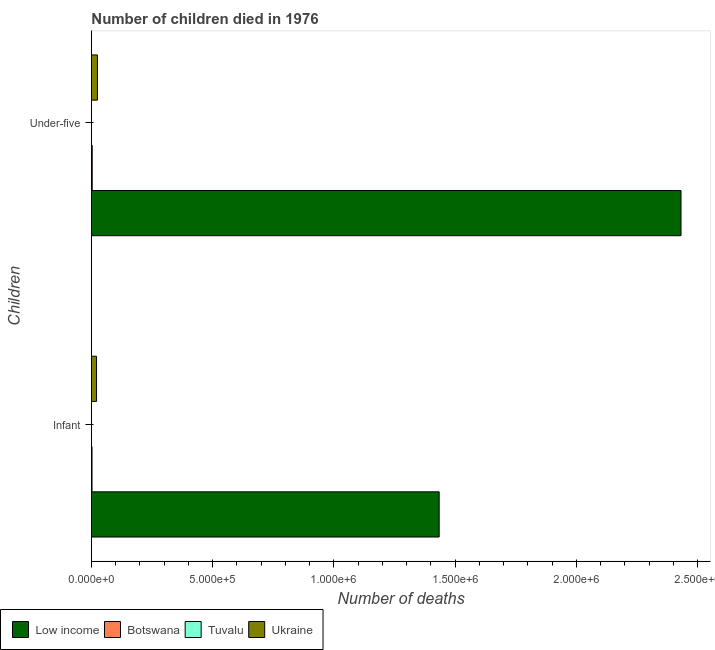How many different coloured bars are there?
Ensure brevity in your answer.  4. Are the number of bars per tick equal to the number of legend labels?
Offer a terse response. Yes. What is the label of the 2nd group of bars from the top?
Offer a terse response. Infant. What is the number of under-five deaths in Low income?
Keep it short and to the point. 2.43e+06. Across all countries, what is the maximum number of infant deaths?
Provide a short and direct response. 1.43e+06. Across all countries, what is the minimum number of under-five deaths?
Your answer should be compact. 15. In which country was the number of infant deaths minimum?
Make the answer very short. Tuvalu. What is the total number of infant deaths in the graph?
Make the answer very short. 1.46e+06. What is the difference between the number of under-five deaths in Tuvalu and that in Ukraine?
Provide a short and direct response. -2.48e+04. What is the difference between the number of infant deaths in Botswana and the number of under-five deaths in Low income?
Your answer should be compact. -2.43e+06. What is the average number of infant deaths per country?
Ensure brevity in your answer.  3.64e+05. What is the difference between the number of infant deaths and number of under-five deaths in Low income?
Offer a very short reply. -9.97e+05. In how many countries, is the number of infant deaths greater than 1200000 ?
Offer a terse response. 1. What is the ratio of the number of under-five deaths in Ukraine to that in Tuvalu?
Your answer should be very brief. 1654.67. Is the number of infant deaths in Tuvalu less than that in Botswana?
Offer a terse response. Yes. What does the 1st bar from the top in Under-five represents?
Your response must be concise. Ukraine. What does the 3rd bar from the bottom in Under-five represents?
Keep it short and to the point. Tuvalu. How many bars are there?
Offer a terse response. 8. Are the values on the major ticks of X-axis written in scientific E-notation?
Keep it short and to the point. Yes. Does the graph contain any zero values?
Provide a short and direct response. No. How are the legend labels stacked?
Provide a succinct answer. Horizontal. What is the title of the graph?
Keep it short and to the point. Number of children died in 1976. Does "Guinea-Bissau" appear as one of the legend labels in the graph?
Provide a short and direct response. No. What is the label or title of the X-axis?
Ensure brevity in your answer.  Number of deaths. What is the label or title of the Y-axis?
Give a very brief answer. Children. What is the Number of deaths in Low income in Infant?
Make the answer very short. 1.43e+06. What is the Number of deaths of Botswana in Infant?
Make the answer very short. 2437. What is the Number of deaths of Ukraine in Infant?
Ensure brevity in your answer.  2.11e+04. What is the Number of deaths in Low income in Under-five?
Your answer should be very brief. 2.43e+06. What is the Number of deaths in Botswana in Under-five?
Provide a short and direct response. 3282. What is the Number of deaths of Tuvalu in Under-five?
Keep it short and to the point. 15. What is the Number of deaths of Ukraine in Under-five?
Offer a terse response. 2.48e+04. Across all Children, what is the maximum Number of deaths of Low income?
Keep it short and to the point. 2.43e+06. Across all Children, what is the maximum Number of deaths of Botswana?
Keep it short and to the point. 3282. Across all Children, what is the maximum Number of deaths in Tuvalu?
Provide a short and direct response. 15. Across all Children, what is the maximum Number of deaths in Ukraine?
Offer a very short reply. 2.48e+04. Across all Children, what is the minimum Number of deaths of Low income?
Provide a succinct answer. 1.43e+06. Across all Children, what is the minimum Number of deaths of Botswana?
Your response must be concise. 2437. Across all Children, what is the minimum Number of deaths of Tuvalu?
Offer a terse response. 11. Across all Children, what is the minimum Number of deaths of Ukraine?
Your answer should be very brief. 2.11e+04. What is the total Number of deaths of Low income in the graph?
Provide a short and direct response. 3.87e+06. What is the total Number of deaths in Botswana in the graph?
Keep it short and to the point. 5719. What is the total Number of deaths in Ukraine in the graph?
Your response must be concise. 4.59e+04. What is the difference between the Number of deaths in Low income in Infant and that in Under-five?
Your response must be concise. -9.97e+05. What is the difference between the Number of deaths in Botswana in Infant and that in Under-five?
Your answer should be very brief. -845. What is the difference between the Number of deaths in Tuvalu in Infant and that in Under-five?
Provide a succinct answer. -4. What is the difference between the Number of deaths in Ukraine in Infant and that in Under-five?
Provide a short and direct response. -3726. What is the difference between the Number of deaths of Low income in Infant and the Number of deaths of Botswana in Under-five?
Keep it short and to the point. 1.43e+06. What is the difference between the Number of deaths in Low income in Infant and the Number of deaths in Tuvalu in Under-five?
Your answer should be compact. 1.43e+06. What is the difference between the Number of deaths of Low income in Infant and the Number of deaths of Ukraine in Under-five?
Your response must be concise. 1.41e+06. What is the difference between the Number of deaths in Botswana in Infant and the Number of deaths in Tuvalu in Under-five?
Your response must be concise. 2422. What is the difference between the Number of deaths of Botswana in Infant and the Number of deaths of Ukraine in Under-five?
Offer a very short reply. -2.24e+04. What is the difference between the Number of deaths in Tuvalu in Infant and the Number of deaths in Ukraine in Under-five?
Keep it short and to the point. -2.48e+04. What is the average Number of deaths in Low income per Children?
Make the answer very short. 1.93e+06. What is the average Number of deaths in Botswana per Children?
Offer a terse response. 2859.5. What is the average Number of deaths in Ukraine per Children?
Give a very brief answer. 2.30e+04. What is the difference between the Number of deaths in Low income and Number of deaths in Botswana in Infant?
Give a very brief answer. 1.43e+06. What is the difference between the Number of deaths of Low income and Number of deaths of Tuvalu in Infant?
Ensure brevity in your answer.  1.43e+06. What is the difference between the Number of deaths in Low income and Number of deaths in Ukraine in Infant?
Provide a succinct answer. 1.41e+06. What is the difference between the Number of deaths of Botswana and Number of deaths of Tuvalu in Infant?
Make the answer very short. 2426. What is the difference between the Number of deaths of Botswana and Number of deaths of Ukraine in Infant?
Offer a very short reply. -1.87e+04. What is the difference between the Number of deaths of Tuvalu and Number of deaths of Ukraine in Infant?
Give a very brief answer. -2.11e+04. What is the difference between the Number of deaths of Low income and Number of deaths of Botswana in Under-five?
Provide a succinct answer. 2.43e+06. What is the difference between the Number of deaths of Low income and Number of deaths of Tuvalu in Under-five?
Give a very brief answer. 2.43e+06. What is the difference between the Number of deaths in Low income and Number of deaths in Ukraine in Under-five?
Offer a very short reply. 2.41e+06. What is the difference between the Number of deaths of Botswana and Number of deaths of Tuvalu in Under-five?
Provide a short and direct response. 3267. What is the difference between the Number of deaths in Botswana and Number of deaths in Ukraine in Under-five?
Keep it short and to the point. -2.15e+04. What is the difference between the Number of deaths in Tuvalu and Number of deaths in Ukraine in Under-five?
Make the answer very short. -2.48e+04. What is the ratio of the Number of deaths in Low income in Infant to that in Under-five?
Ensure brevity in your answer.  0.59. What is the ratio of the Number of deaths of Botswana in Infant to that in Under-five?
Offer a very short reply. 0.74. What is the ratio of the Number of deaths of Tuvalu in Infant to that in Under-five?
Give a very brief answer. 0.73. What is the ratio of the Number of deaths of Ukraine in Infant to that in Under-five?
Give a very brief answer. 0.85. What is the difference between the highest and the second highest Number of deaths of Low income?
Make the answer very short. 9.97e+05. What is the difference between the highest and the second highest Number of deaths in Botswana?
Offer a terse response. 845. What is the difference between the highest and the second highest Number of deaths in Ukraine?
Your response must be concise. 3726. What is the difference between the highest and the lowest Number of deaths of Low income?
Make the answer very short. 9.97e+05. What is the difference between the highest and the lowest Number of deaths of Botswana?
Make the answer very short. 845. What is the difference between the highest and the lowest Number of deaths in Ukraine?
Make the answer very short. 3726. 